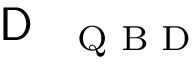<formula> <loc_0><loc_0><loc_500><loc_500>D _ { Q B D }</formula> 